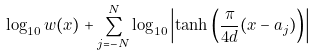Convert formula to latex. <formula><loc_0><loc_0><loc_500><loc_500>\log _ { 1 0 } w ( x ) + \sum _ { j = - N } ^ { N } \log _ { 1 0 } \left | \tanh \left ( \frac { \pi } { 4 d } ( x - a _ { j } ) \right ) \right |</formula> 